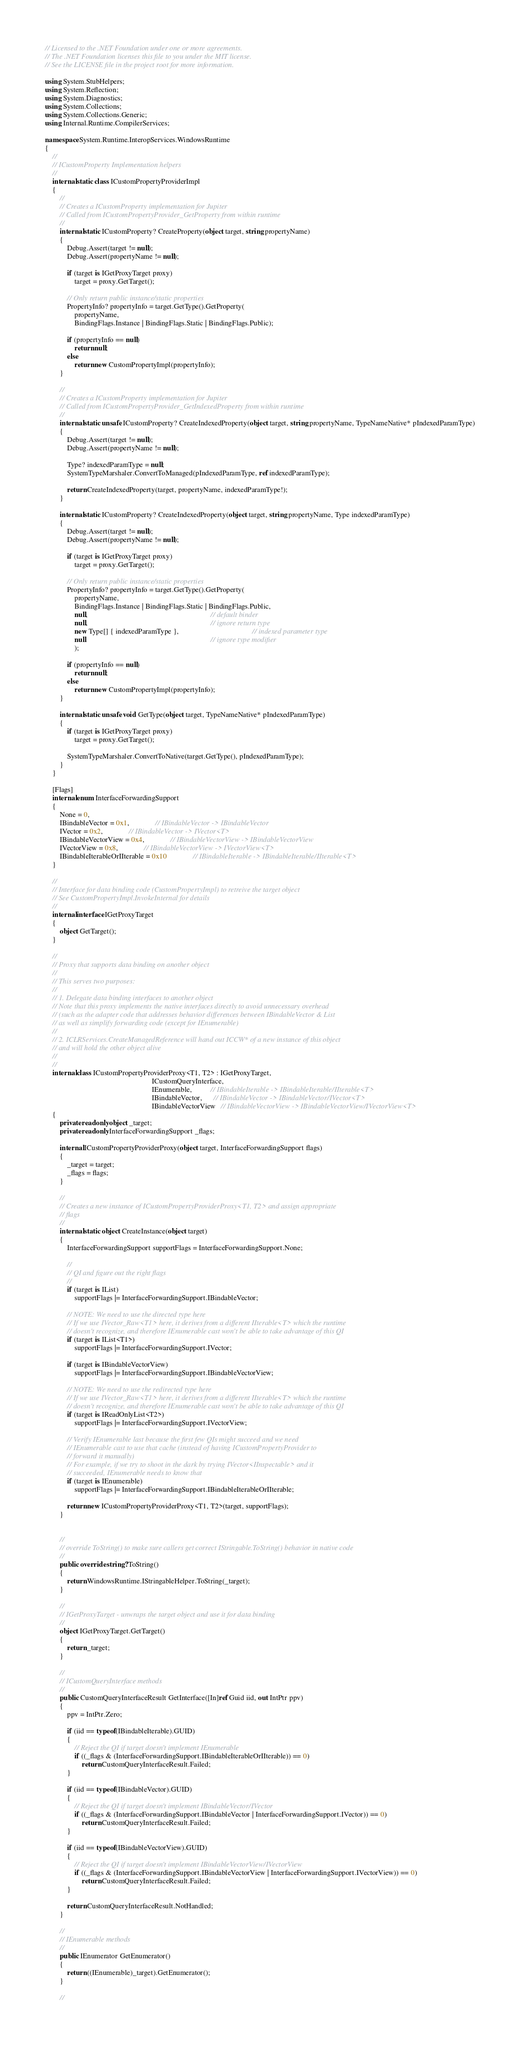Convert code to text. <code><loc_0><loc_0><loc_500><loc_500><_C#_>// Licensed to the .NET Foundation under one or more agreements.
// The .NET Foundation licenses this file to you under the MIT license.
// See the LICENSE file in the project root for more information.

using System.StubHelpers;
using System.Reflection;
using System.Diagnostics;
using System.Collections;
using System.Collections.Generic;
using Internal.Runtime.CompilerServices;

namespace System.Runtime.InteropServices.WindowsRuntime
{
    //
    // ICustomProperty Implementation helpers
    //
    internal static class ICustomPropertyProviderImpl
    {
        //
        // Creates a ICustomProperty implementation for Jupiter
        // Called from ICustomPropertyProvider_GetProperty from within runtime
        //
        internal static ICustomProperty? CreateProperty(object target, string propertyName)
        {
            Debug.Assert(target != null);
            Debug.Assert(propertyName != null);

            if (target is IGetProxyTarget proxy)
                target = proxy.GetTarget();

            // Only return public instance/static properties
            PropertyInfo? propertyInfo = target.GetType().GetProperty(
                propertyName,
                BindingFlags.Instance | BindingFlags.Static | BindingFlags.Public);

            if (propertyInfo == null)
                return null;
            else
                return new CustomPropertyImpl(propertyInfo);
        }

        //
        // Creates a ICustomProperty implementation for Jupiter
        // Called from ICustomPropertyProvider_GetIndexedProperty from within runtime
        //
        internal static unsafe ICustomProperty? CreateIndexedProperty(object target, string propertyName, TypeNameNative* pIndexedParamType)
        {
            Debug.Assert(target != null);
            Debug.Assert(propertyName != null);

            Type? indexedParamType = null;
            SystemTypeMarshaler.ConvertToManaged(pIndexedParamType, ref indexedParamType);

            return CreateIndexedProperty(target, propertyName, indexedParamType!);
        }

        internal static ICustomProperty? CreateIndexedProperty(object target, string propertyName, Type indexedParamType)
        {
            Debug.Assert(target != null);
            Debug.Assert(propertyName != null);

            if (target is IGetProxyTarget proxy)
                target = proxy.GetTarget();

            // Only return public instance/static properties
            PropertyInfo? propertyInfo = target.GetType().GetProperty(
                propertyName,
                BindingFlags.Instance | BindingFlags.Static | BindingFlags.Public,
                null,                                                                   // default binder
                null,                                                                   // ignore return type
                new Type[] { indexedParamType },                                        // indexed parameter type
                null                                                                    // ignore type modifier
                );

            if (propertyInfo == null)
                return null;
            else
                return new CustomPropertyImpl(propertyInfo);
        }

        internal static unsafe void GetType(object target, TypeNameNative* pIndexedParamType)
        {
            if (target is IGetProxyTarget proxy)
                target = proxy.GetTarget();

            SystemTypeMarshaler.ConvertToNative(target.GetType(), pIndexedParamType);
        }
    }

    [Flags]
    internal enum InterfaceForwardingSupport
    {
        None = 0,
        IBindableVector = 0x1,              // IBindableVector -> IBindableVector
        IVector = 0x2,              // IBindableVector -> IVector<T>
        IBindableVectorView = 0x4,              // IBindableVectorView -> IBindableVectorView
        IVectorView = 0x8,              // IBindableVectorView -> IVectorView<T>
        IBindableIterableOrIIterable = 0x10              // IBindableIterable -> IBindableIterable/IIterable<T>
    }

    //
    // Interface for data binding code (CustomPropertyImpl) to retreive the target object
    // See CustomPropertyImpl.InvokeInternal for details
    //
    internal interface IGetProxyTarget
    {
        object GetTarget();
    }

    //
    // Proxy that supports data binding on another object
    //
    // This serves two purposes:
    //
    // 1. Delegate data binding interfaces to another object
    // Note that this proxy implements the native interfaces directly to avoid unnecessary overhead
    // (such as the adapter code that addresses behavior differences between IBindableVector & List
    // as well as simplify forwarding code (except for IEnumerable)
    //
    // 2. ICLRServices.CreateManagedReference will hand out ICCW* of a new instance of this object
    // and will hold the other object alive
    //
    //
    internal class ICustomPropertyProviderProxy<T1, T2> : IGetProxyTarget,
                                                          ICustomQueryInterface,
                                                          IEnumerable,          // IBindableIterable -> IBindableIterable/IIterable<T>
                                                          IBindableVector,      // IBindableVector -> IBindableVector/IVector<T>
                                                          IBindableVectorView   // IBindableVectorView -> IBindableVectorView/IVectorView<T>
    {
        private readonly object _target;
        private readonly InterfaceForwardingSupport _flags;

        internal ICustomPropertyProviderProxy(object target, InterfaceForwardingSupport flags)
        {
            _target = target;
            _flags = flags;
        }

        //
        // Creates a new instance of ICustomPropertyProviderProxy<T1, T2> and assign appropriate
        // flags
        //
        internal static object CreateInstance(object target)
        {
            InterfaceForwardingSupport supportFlags = InterfaceForwardingSupport.None;

            //
            // QI and figure out the right flags
            //
            if (target is IList)
                supportFlags |= InterfaceForwardingSupport.IBindableVector;

            // NOTE: We need to use the directed type here
            // If we use IVector_Raw<T1> here, it derives from a different IIterable<T> which the runtime
            // doesn't recognize, and therefore IEnumerable cast won't be able to take advantage of this QI
            if (target is IList<T1>)
                supportFlags |= InterfaceForwardingSupport.IVector;

            if (target is IBindableVectorView)
                supportFlags |= InterfaceForwardingSupport.IBindableVectorView;

            // NOTE: We need to use the redirected type here
            // If we use IVector_Raw<T1> here, it derives from a different IIterable<T> which the runtime
            // doesn't recognize, and therefore IEnumerable cast won't be able to take advantage of this QI
            if (target is IReadOnlyList<T2>)
                supportFlags |= InterfaceForwardingSupport.IVectorView;

            // Verify IEnumerable last because the first few QIs might succeed and we need
            // IEnumerable cast to use that cache (instead of having ICustomPropertyProvider to
            // forward it manually)
            // For example, if we try to shoot in the dark by trying IVector<IInspectable> and it
            // succeeded, IEnumerable needs to know that
            if (target is IEnumerable)
                supportFlags |= InterfaceForwardingSupport.IBindableIterableOrIIterable;

            return new ICustomPropertyProviderProxy<T1, T2>(target, supportFlags);
        }


        //
        // override ToString() to make sure callers get correct IStringable.ToString() behavior in native code
        //
        public override string? ToString()
        {
            return WindowsRuntime.IStringableHelper.ToString(_target);
        }

        //
        // IGetProxyTarget - unwraps the target object and use it for data binding
        //
        object IGetProxyTarget.GetTarget()
        {
            return _target;
        }

        //
        // ICustomQueryInterface methods
        //
        public CustomQueryInterfaceResult GetInterface([In]ref Guid iid, out IntPtr ppv)
        {
            ppv = IntPtr.Zero;

            if (iid == typeof(IBindableIterable).GUID)
            {
                // Reject the QI if target doesn't implement IEnumerable
                if ((_flags & (InterfaceForwardingSupport.IBindableIterableOrIIterable)) == 0)
                    return CustomQueryInterfaceResult.Failed;
            }

            if (iid == typeof(IBindableVector).GUID)
            {
                // Reject the QI if target doesn't implement IBindableVector/IVector
                if ((_flags & (InterfaceForwardingSupport.IBindableVector | InterfaceForwardingSupport.IVector)) == 0)
                    return CustomQueryInterfaceResult.Failed;
            }

            if (iid == typeof(IBindableVectorView).GUID)
            {
                // Reject the QI if target doesn't implement IBindableVectorView/IVectorView
                if ((_flags & (InterfaceForwardingSupport.IBindableVectorView | InterfaceForwardingSupport.IVectorView)) == 0)
                    return CustomQueryInterfaceResult.Failed;
            }

            return CustomQueryInterfaceResult.NotHandled;
        }

        //
        // IEnumerable methods
        //
        public IEnumerator GetEnumerator()
        {
            return ((IEnumerable)_target).GetEnumerator();
        }

        //</code> 